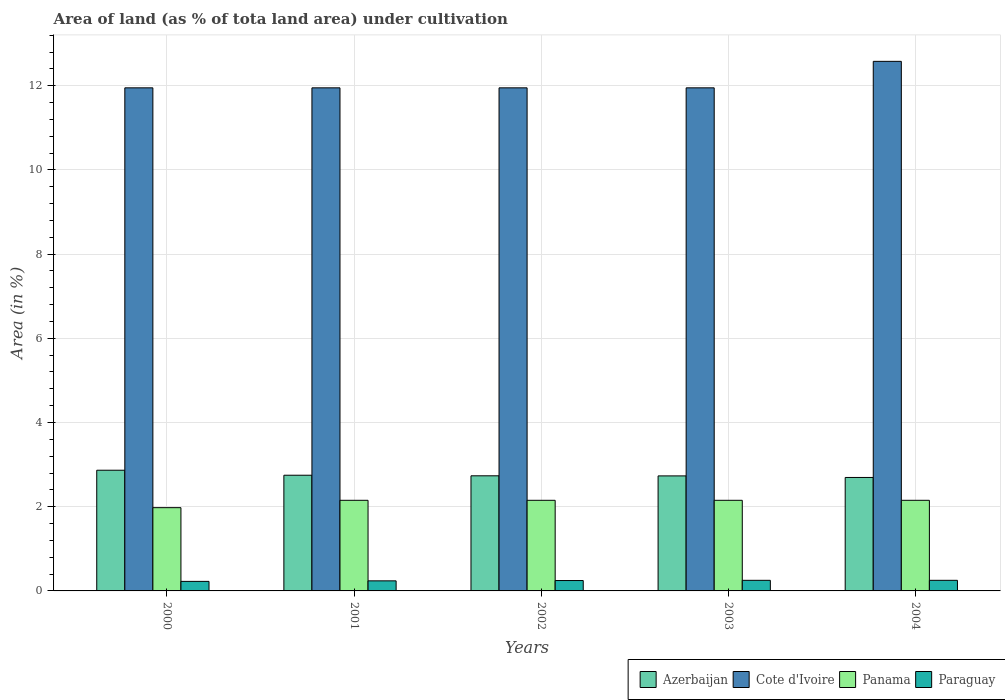How many different coloured bars are there?
Your response must be concise. 4. Are the number of bars per tick equal to the number of legend labels?
Provide a succinct answer. Yes. What is the label of the 1st group of bars from the left?
Make the answer very short. 2000. In how many cases, is the number of bars for a given year not equal to the number of legend labels?
Your answer should be very brief. 0. What is the percentage of land under cultivation in Cote d'Ivoire in 2004?
Give a very brief answer. 12.58. Across all years, what is the maximum percentage of land under cultivation in Azerbaijan?
Keep it short and to the point. 2.87. Across all years, what is the minimum percentage of land under cultivation in Paraguay?
Ensure brevity in your answer.  0.23. In which year was the percentage of land under cultivation in Panama maximum?
Your answer should be very brief. 2001. In which year was the percentage of land under cultivation in Azerbaijan minimum?
Provide a short and direct response. 2004. What is the total percentage of land under cultivation in Azerbaijan in the graph?
Your answer should be compact. 13.78. What is the difference between the percentage of land under cultivation in Panama in 2000 and that in 2003?
Keep it short and to the point. -0.17. What is the difference between the percentage of land under cultivation in Paraguay in 2000 and the percentage of land under cultivation in Cote d'Ivoire in 2004?
Provide a succinct answer. -12.35. What is the average percentage of land under cultivation in Paraguay per year?
Your answer should be compact. 0.24. In the year 2001, what is the difference between the percentage of land under cultivation in Paraguay and percentage of land under cultivation in Panama?
Your answer should be very brief. -1.91. In how many years, is the percentage of land under cultivation in Paraguay greater than 2.4 %?
Keep it short and to the point. 0. What is the ratio of the percentage of land under cultivation in Panama in 2000 to that in 2004?
Your answer should be very brief. 0.92. What is the difference between the highest and the second highest percentage of land under cultivation in Panama?
Your response must be concise. 0. What is the difference between the highest and the lowest percentage of land under cultivation in Cote d'Ivoire?
Your answer should be very brief. 0.63. In how many years, is the percentage of land under cultivation in Panama greater than the average percentage of land under cultivation in Panama taken over all years?
Ensure brevity in your answer.  4. Is it the case that in every year, the sum of the percentage of land under cultivation in Panama and percentage of land under cultivation in Paraguay is greater than the sum of percentage of land under cultivation in Azerbaijan and percentage of land under cultivation in Cote d'Ivoire?
Provide a short and direct response. No. What does the 3rd bar from the left in 2002 represents?
Give a very brief answer. Panama. What does the 1st bar from the right in 2000 represents?
Give a very brief answer. Paraguay. Is it the case that in every year, the sum of the percentage of land under cultivation in Azerbaijan and percentage of land under cultivation in Cote d'Ivoire is greater than the percentage of land under cultivation in Panama?
Your answer should be very brief. Yes. How many bars are there?
Give a very brief answer. 20. Are all the bars in the graph horizontal?
Your response must be concise. No. How many years are there in the graph?
Provide a succinct answer. 5. Does the graph contain grids?
Make the answer very short. Yes. Where does the legend appear in the graph?
Provide a succinct answer. Bottom right. How many legend labels are there?
Offer a terse response. 4. How are the legend labels stacked?
Provide a short and direct response. Horizontal. What is the title of the graph?
Make the answer very short. Area of land (as % of tota land area) under cultivation. What is the label or title of the Y-axis?
Your answer should be compact. Area (in %). What is the Area (in %) of Azerbaijan in 2000?
Your response must be concise. 2.87. What is the Area (in %) of Cote d'Ivoire in 2000?
Ensure brevity in your answer.  11.95. What is the Area (in %) of Panama in 2000?
Your answer should be very brief. 1.98. What is the Area (in %) in Paraguay in 2000?
Provide a succinct answer. 0.23. What is the Area (in %) in Azerbaijan in 2001?
Make the answer very short. 2.75. What is the Area (in %) in Cote d'Ivoire in 2001?
Your response must be concise. 11.95. What is the Area (in %) of Panama in 2001?
Your answer should be very brief. 2.15. What is the Area (in %) in Paraguay in 2001?
Provide a succinct answer. 0.24. What is the Area (in %) in Azerbaijan in 2002?
Make the answer very short. 2.73. What is the Area (in %) of Cote d'Ivoire in 2002?
Your response must be concise. 11.95. What is the Area (in %) of Panama in 2002?
Offer a terse response. 2.15. What is the Area (in %) in Paraguay in 2002?
Give a very brief answer. 0.25. What is the Area (in %) of Azerbaijan in 2003?
Provide a succinct answer. 2.73. What is the Area (in %) of Cote d'Ivoire in 2003?
Keep it short and to the point. 11.95. What is the Area (in %) of Panama in 2003?
Your response must be concise. 2.15. What is the Area (in %) of Paraguay in 2003?
Provide a succinct answer. 0.25. What is the Area (in %) in Azerbaijan in 2004?
Your answer should be compact. 2.69. What is the Area (in %) in Cote d'Ivoire in 2004?
Provide a short and direct response. 12.58. What is the Area (in %) of Panama in 2004?
Provide a succinct answer. 2.15. What is the Area (in %) in Paraguay in 2004?
Provide a succinct answer. 0.25. Across all years, what is the maximum Area (in %) of Azerbaijan?
Give a very brief answer. 2.87. Across all years, what is the maximum Area (in %) of Cote d'Ivoire?
Give a very brief answer. 12.58. Across all years, what is the maximum Area (in %) of Panama?
Offer a terse response. 2.15. Across all years, what is the maximum Area (in %) of Paraguay?
Make the answer very short. 0.25. Across all years, what is the minimum Area (in %) in Azerbaijan?
Give a very brief answer. 2.69. Across all years, what is the minimum Area (in %) of Cote d'Ivoire?
Ensure brevity in your answer.  11.95. Across all years, what is the minimum Area (in %) of Panama?
Provide a short and direct response. 1.98. Across all years, what is the minimum Area (in %) of Paraguay?
Keep it short and to the point. 0.23. What is the total Area (in %) in Azerbaijan in the graph?
Your response must be concise. 13.78. What is the total Area (in %) of Cote d'Ivoire in the graph?
Offer a terse response. 60.38. What is the total Area (in %) of Panama in the graph?
Provide a succinct answer. 10.59. What is the total Area (in %) of Paraguay in the graph?
Your answer should be compact. 1.22. What is the difference between the Area (in %) in Azerbaijan in 2000 and that in 2001?
Make the answer very short. 0.12. What is the difference between the Area (in %) of Panama in 2000 and that in 2001?
Your answer should be very brief. -0.17. What is the difference between the Area (in %) in Paraguay in 2000 and that in 2001?
Your answer should be very brief. -0.01. What is the difference between the Area (in %) in Azerbaijan in 2000 and that in 2002?
Your answer should be very brief. 0.13. What is the difference between the Area (in %) of Panama in 2000 and that in 2002?
Offer a very short reply. -0.17. What is the difference between the Area (in %) of Paraguay in 2000 and that in 2002?
Ensure brevity in your answer.  -0.02. What is the difference between the Area (in %) in Azerbaijan in 2000 and that in 2003?
Ensure brevity in your answer.  0.13. What is the difference between the Area (in %) of Panama in 2000 and that in 2003?
Make the answer very short. -0.17. What is the difference between the Area (in %) in Paraguay in 2000 and that in 2003?
Provide a succinct answer. -0.03. What is the difference between the Area (in %) of Azerbaijan in 2000 and that in 2004?
Offer a terse response. 0.17. What is the difference between the Area (in %) of Cote d'Ivoire in 2000 and that in 2004?
Provide a succinct answer. -0.63. What is the difference between the Area (in %) of Panama in 2000 and that in 2004?
Keep it short and to the point. -0.17. What is the difference between the Area (in %) of Paraguay in 2000 and that in 2004?
Give a very brief answer. -0.03. What is the difference between the Area (in %) of Azerbaijan in 2001 and that in 2002?
Your response must be concise. 0.01. What is the difference between the Area (in %) in Cote d'Ivoire in 2001 and that in 2002?
Offer a terse response. 0. What is the difference between the Area (in %) in Paraguay in 2001 and that in 2002?
Your answer should be very brief. -0.01. What is the difference between the Area (in %) of Azerbaijan in 2001 and that in 2003?
Keep it short and to the point. 0.02. What is the difference between the Area (in %) of Panama in 2001 and that in 2003?
Offer a very short reply. 0. What is the difference between the Area (in %) of Paraguay in 2001 and that in 2003?
Provide a succinct answer. -0.01. What is the difference between the Area (in %) of Azerbaijan in 2001 and that in 2004?
Your answer should be compact. 0.05. What is the difference between the Area (in %) of Cote d'Ivoire in 2001 and that in 2004?
Your answer should be compact. -0.63. What is the difference between the Area (in %) of Panama in 2001 and that in 2004?
Provide a short and direct response. 0. What is the difference between the Area (in %) of Paraguay in 2001 and that in 2004?
Your response must be concise. -0.01. What is the difference between the Area (in %) of Azerbaijan in 2002 and that in 2003?
Your answer should be compact. 0. What is the difference between the Area (in %) of Paraguay in 2002 and that in 2003?
Keep it short and to the point. -0.01. What is the difference between the Area (in %) of Azerbaijan in 2002 and that in 2004?
Provide a succinct answer. 0.04. What is the difference between the Area (in %) in Cote d'Ivoire in 2002 and that in 2004?
Offer a terse response. -0.63. What is the difference between the Area (in %) in Panama in 2002 and that in 2004?
Ensure brevity in your answer.  0. What is the difference between the Area (in %) in Paraguay in 2002 and that in 2004?
Make the answer very short. -0.01. What is the difference between the Area (in %) in Azerbaijan in 2003 and that in 2004?
Provide a short and direct response. 0.04. What is the difference between the Area (in %) in Cote d'Ivoire in 2003 and that in 2004?
Offer a very short reply. -0.63. What is the difference between the Area (in %) of Azerbaijan in 2000 and the Area (in %) of Cote d'Ivoire in 2001?
Offer a terse response. -9.08. What is the difference between the Area (in %) of Azerbaijan in 2000 and the Area (in %) of Panama in 2001?
Ensure brevity in your answer.  0.71. What is the difference between the Area (in %) in Azerbaijan in 2000 and the Area (in %) in Paraguay in 2001?
Ensure brevity in your answer.  2.63. What is the difference between the Area (in %) of Cote d'Ivoire in 2000 and the Area (in %) of Panama in 2001?
Your answer should be compact. 9.8. What is the difference between the Area (in %) of Cote d'Ivoire in 2000 and the Area (in %) of Paraguay in 2001?
Your answer should be compact. 11.71. What is the difference between the Area (in %) of Panama in 2000 and the Area (in %) of Paraguay in 2001?
Your answer should be compact. 1.74. What is the difference between the Area (in %) of Azerbaijan in 2000 and the Area (in %) of Cote d'Ivoire in 2002?
Make the answer very short. -9.08. What is the difference between the Area (in %) of Azerbaijan in 2000 and the Area (in %) of Panama in 2002?
Your answer should be very brief. 0.71. What is the difference between the Area (in %) of Azerbaijan in 2000 and the Area (in %) of Paraguay in 2002?
Offer a terse response. 2.62. What is the difference between the Area (in %) of Cote d'Ivoire in 2000 and the Area (in %) of Panama in 2002?
Make the answer very short. 9.8. What is the difference between the Area (in %) of Cote d'Ivoire in 2000 and the Area (in %) of Paraguay in 2002?
Your answer should be compact. 11.7. What is the difference between the Area (in %) in Panama in 2000 and the Area (in %) in Paraguay in 2002?
Your answer should be compact. 1.73. What is the difference between the Area (in %) in Azerbaijan in 2000 and the Area (in %) in Cote d'Ivoire in 2003?
Your response must be concise. -9.08. What is the difference between the Area (in %) in Azerbaijan in 2000 and the Area (in %) in Panama in 2003?
Provide a short and direct response. 0.71. What is the difference between the Area (in %) in Azerbaijan in 2000 and the Area (in %) in Paraguay in 2003?
Your response must be concise. 2.62. What is the difference between the Area (in %) in Cote d'Ivoire in 2000 and the Area (in %) in Panama in 2003?
Provide a succinct answer. 9.8. What is the difference between the Area (in %) in Cote d'Ivoire in 2000 and the Area (in %) in Paraguay in 2003?
Your answer should be compact. 11.7. What is the difference between the Area (in %) in Panama in 2000 and the Area (in %) in Paraguay in 2003?
Make the answer very short. 1.73. What is the difference between the Area (in %) in Azerbaijan in 2000 and the Area (in %) in Cote d'Ivoire in 2004?
Keep it short and to the point. -9.71. What is the difference between the Area (in %) of Azerbaijan in 2000 and the Area (in %) of Panama in 2004?
Your answer should be compact. 0.71. What is the difference between the Area (in %) of Azerbaijan in 2000 and the Area (in %) of Paraguay in 2004?
Make the answer very short. 2.62. What is the difference between the Area (in %) of Cote d'Ivoire in 2000 and the Area (in %) of Panama in 2004?
Keep it short and to the point. 9.8. What is the difference between the Area (in %) in Cote d'Ivoire in 2000 and the Area (in %) in Paraguay in 2004?
Give a very brief answer. 11.7. What is the difference between the Area (in %) of Panama in 2000 and the Area (in %) of Paraguay in 2004?
Provide a short and direct response. 1.73. What is the difference between the Area (in %) in Azerbaijan in 2001 and the Area (in %) in Cote d'Ivoire in 2002?
Offer a terse response. -9.2. What is the difference between the Area (in %) of Azerbaijan in 2001 and the Area (in %) of Panama in 2002?
Keep it short and to the point. 0.6. What is the difference between the Area (in %) in Azerbaijan in 2001 and the Area (in %) in Paraguay in 2002?
Make the answer very short. 2.5. What is the difference between the Area (in %) of Cote d'Ivoire in 2001 and the Area (in %) of Panama in 2002?
Provide a succinct answer. 9.8. What is the difference between the Area (in %) of Cote d'Ivoire in 2001 and the Area (in %) of Paraguay in 2002?
Keep it short and to the point. 11.7. What is the difference between the Area (in %) of Panama in 2001 and the Area (in %) of Paraguay in 2002?
Offer a very short reply. 1.91. What is the difference between the Area (in %) in Azerbaijan in 2001 and the Area (in %) in Cote d'Ivoire in 2003?
Your response must be concise. -9.2. What is the difference between the Area (in %) of Azerbaijan in 2001 and the Area (in %) of Panama in 2003?
Your answer should be compact. 0.6. What is the difference between the Area (in %) of Azerbaijan in 2001 and the Area (in %) of Paraguay in 2003?
Offer a terse response. 2.5. What is the difference between the Area (in %) of Cote d'Ivoire in 2001 and the Area (in %) of Panama in 2003?
Offer a terse response. 9.8. What is the difference between the Area (in %) in Cote d'Ivoire in 2001 and the Area (in %) in Paraguay in 2003?
Provide a short and direct response. 11.7. What is the difference between the Area (in %) in Panama in 2001 and the Area (in %) in Paraguay in 2003?
Ensure brevity in your answer.  1.9. What is the difference between the Area (in %) in Azerbaijan in 2001 and the Area (in %) in Cote d'Ivoire in 2004?
Your response must be concise. -9.83. What is the difference between the Area (in %) of Azerbaijan in 2001 and the Area (in %) of Panama in 2004?
Offer a very short reply. 0.6. What is the difference between the Area (in %) in Azerbaijan in 2001 and the Area (in %) in Paraguay in 2004?
Give a very brief answer. 2.5. What is the difference between the Area (in %) in Cote d'Ivoire in 2001 and the Area (in %) in Panama in 2004?
Provide a short and direct response. 9.8. What is the difference between the Area (in %) in Cote d'Ivoire in 2001 and the Area (in %) in Paraguay in 2004?
Provide a short and direct response. 11.7. What is the difference between the Area (in %) of Panama in 2001 and the Area (in %) of Paraguay in 2004?
Your answer should be very brief. 1.9. What is the difference between the Area (in %) of Azerbaijan in 2002 and the Area (in %) of Cote d'Ivoire in 2003?
Provide a succinct answer. -9.22. What is the difference between the Area (in %) of Azerbaijan in 2002 and the Area (in %) of Panama in 2003?
Your answer should be very brief. 0.58. What is the difference between the Area (in %) of Azerbaijan in 2002 and the Area (in %) of Paraguay in 2003?
Keep it short and to the point. 2.48. What is the difference between the Area (in %) of Cote d'Ivoire in 2002 and the Area (in %) of Panama in 2003?
Give a very brief answer. 9.8. What is the difference between the Area (in %) in Cote d'Ivoire in 2002 and the Area (in %) in Paraguay in 2003?
Offer a very short reply. 11.7. What is the difference between the Area (in %) of Panama in 2002 and the Area (in %) of Paraguay in 2003?
Offer a very short reply. 1.9. What is the difference between the Area (in %) of Azerbaijan in 2002 and the Area (in %) of Cote d'Ivoire in 2004?
Make the answer very short. -9.84. What is the difference between the Area (in %) of Azerbaijan in 2002 and the Area (in %) of Panama in 2004?
Offer a very short reply. 0.58. What is the difference between the Area (in %) of Azerbaijan in 2002 and the Area (in %) of Paraguay in 2004?
Keep it short and to the point. 2.48. What is the difference between the Area (in %) in Cote d'Ivoire in 2002 and the Area (in %) in Panama in 2004?
Give a very brief answer. 9.8. What is the difference between the Area (in %) in Cote d'Ivoire in 2002 and the Area (in %) in Paraguay in 2004?
Keep it short and to the point. 11.7. What is the difference between the Area (in %) in Panama in 2002 and the Area (in %) in Paraguay in 2004?
Ensure brevity in your answer.  1.9. What is the difference between the Area (in %) of Azerbaijan in 2003 and the Area (in %) of Cote d'Ivoire in 2004?
Give a very brief answer. -9.85. What is the difference between the Area (in %) of Azerbaijan in 2003 and the Area (in %) of Panama in 2004?
Offer a very short reply. 0.58. What is the difference between the Area (in %) in Azerbaijan in 2003 and the Area (in %) in Paraguay in 2004?
Keep it short and to the point. 2.48. What is the difference between the Area (in %) of Cote d'Ivoire in 2003 and the Area (in %) of Panama in 2004?
Give a very brief answer. 9.8. What is the difference between the Area (in %) in Cote d'Ivoire in 2003 and the Area (in %) in Paraguay in 2004?
Offer a very short reply. 11.7. What is the difference between the Area (in %) in Panama in 2003 and the Area (in %) in Paraguay in 2004?
Your answer should be compact. 1.9. What is the average Area (in %) of Azerbaijan per year?
Offer a very short reply. 2.76. What is the average Area (in %) in Cote d'Ivoire per year?
Your response must be concise. 12.08. What is the average Area (in %) in Panama per year?
Give a very brief answer. 2.12. What is the average Area (in %) of Paraguay per year?
Offer a very short reply. 0.24. In the year 2000, what is the difference between the Area (in %) in Azerbaijan and Area (in %) in Cote d'Ivoire?
Ensure brevity in your answer.  -9.08. In the year 2000, what is the difference between the Area (in %) of Azerbaijan and Area (in %) of Panama?
Offer a very short reply. 0.89. In the year 2000, what is the difference between the Area (in %) of Azerbaijan and Area (in %) of Paraguay?
Your response must be concise. 2.64. In the year 2000, what is the difference between the Area (in %) in Cote d'Ivoire and Area (in %) in Panama?
Keep it short and to the point. 9.97. In the year 2000, what is the difference between the Area (in %) of Cote d'Ivoire and Area (in %) of Paraguay?
Provide a short and direct response. 11.72. In the year 2000, what is the difference between the Area (in %) of Panama and Area (in %) of Paraguay?
Ensure brevity in your answer.  1.75. In the year 2001, what is the difference between the Area (in %) of Azerbaijan and Area (in %) of Cote d'Ivoire?
Give a very brief answer. -9.2. In the year 2001, what is the difference between the Area (in %) in Azerbaijan and Area (in %) in Panama?
Ensure brevity in your answer.  0.6. In the year 2001, what is the difference between the Area (in %) in Azerbaijan and Area (in %) in Paraguay?
Offer a terse response. 2.51. In the year 2001, what is the difference between the Area (in %) in Cote d'Ivoire and Area (in %) in Panama?
Offer a very short reply. 9.8. In the year 2001, what is the difference between the Area (in %) in Cote d'Ivoire and Area (in %) in Paraguay?
Provide a succinct answer. 11.71. In the year 2001, what is the difference between the Area (in %) of Panama and Area (in %) of Paraguay?
Your answer should be very brief. 1.91. In the year 2002, what is the difference between the Area (in %) in Azerbaijan and Area (in %) in Cote d'Ivoire?
Your answer should be very brief. -9.22. In the year 2002, what is the difference between the Area (in %) in Azerbaijan and Area (in %) in Panama?
Provide a succinct answer. 0.58. In the year 2002, what is the difference between the Area (in %) of Azerbaijan and Area (in %) of Paraguay?
Provide a succinct answer. 2.49. In the year 2002, what is the difference between the Area (in %) in Cote d'Ivoire and Area (in %) in Panama?
Your answer should be compact. 9.8. In the year 2002, what is the difference between the Area (in %) in Cote d'Ivoire and Area (in %) in Paraguay?
Give a very brief answer. 11.7. In the year 2002, what is the difference between the Area (in %) in Panama and Area (in %) in Paraguay?
Offer a terse response. 1.91. In the year 2003, what is the difference between the Area (in %) in Azerbaijan and Area (in %) in Cote d'Ivoire?
Your answer should be compact. -9.22. In the year 2003, what is the difference between the Area (in %) of Azerbaijan and Area (in %) of Panama?
Your answer should be very brief. 0.58. In the year 2003, what is the difference between the Area (in %) of Azerbaijan and Area (in %) of Paraguay?
Provide a short and direct response. 2.48. In the year 2003, what is the difference between the Area (in %) in Cote d'Ivoire and Area (in %) in Panama?
Ensure brevity in your answer.  9.8. In the year 2003, what is the difference between the Area (in %) in Cote d'Ivoire and Area (in %) in Paraguay?
Make the answer very short. 11.7. In the year 2003, what is the difference between the Area (in %) of Panama and Area (in %) of Paraguay?
Your answer should be compact. 1.9. In the year 2004, what is the difference between the Area (in %) in Azerbaijan and Area (in %) in Cote d'Ivoire?
Make the answer very short. -9.88. In the year 2004, what is the difference between the Area (in %) of Azerbaijan and Area (in %) of Panama?
Your answer should be compact. 0.54. In the year 2004, what is the difference between the Area (in %) of Azerbaijan and Area (in %) of Paraguay?
Your answer should be compact. 2.44. In the year 2004, what is the difference between the Area (in %) of Cote d'Ivoire and Area (in %) of Panama?
Your response must be concise. 10.43. In the year 2004, what is the difference between the Area (in %) of Cote d'Ivoire and Area (in %) of Paraguay?
Your response must be concise. 12.33. In the year 2004, what is the difference between the Area (in %) of Panama and Area (in %) of Paraguay?
Keep it short and to the point. 1.9. What is the ratio of the Area (in %) of Azerbaijan in 2000 to that in 2001?
Offer a terse response. 1.04. What is the ratio of the Area (in %) in Panama in 2000 to that in 2001?
Provide a succinct answer. 0.92. What is the ratio of the Area (in %) in Paraguay in 2000 to that in 2001?
Your answer should be very brief. 0.95. What is the ratio of the Area (in %) in Azerbaijan in 2000 to that in 2002?
Provide a short and direct response. 1.05. What is the ratio of the Area (in %) of Panama in 2000 to that in 2002?
Your response must be concise. 0.92. What is the ratio of the Area (in %) in Paraguay in 2000 to that in 2002?
Offer a terse response. 0.92. What is the ratio of the Area (in %) in Azerbaijan in 2000 to that in 2003?
Make the answer very short. 1.05. What is the ratio of the Area (in %) in Cote d'Ivoire in 2000 to that in 2003?
Offer a terse response. 1. What is the ratio of the Area (in %) in Panama in 2000 to that in 2003?
Your answer should be compact. 0.92. What is the ratio of the Area (in %) of Paraguay in 2000 to that in 2003?
Ensure brevity in your answer.  0.9. What is the ratio of the Area (in %) of Azerbaijan in 2000 to that in 2004?
Your response must be concise. 1.06. What is the ratio of the Area (in %) in Panama in 2000 to that in 2004?
Keep it short and to the point. 0.92. What is the ratio of the Area (in %) of Cote d'Ivoire in 2001 to that in 2002?
Offer a very short reply. 1. What is the ratio of the Area (in %) of Panama in 2001 to that in 2002?
Make the answer very short. 1. What is the ratio of the Area (in %) of Paraguay in 2001 to that in 2002?
Provide a short and direct response. 0.97. What is the ratio of the Area (in %) of Azerbaijan in 2001 to that in 2003?
Your answer should be very brief. 1.01. What is the ratio of the Area (in %) of Azerbaijan in 2001 to that in 2004?
Your response must be concise. 1.02. What is the ratio of the Area (in %) of Paraguay in 2001 to that in 2004?
Ensure brevity in your answer.  0.95. What is the ratio of the Area (in %) of Azerbaijan in 2002 to that in 2003?
Keep it short and to the point. 1. What is the ratio of the Area (in %) in Paraguay in 2002 to that in 2003?
Keep it short and to the point. 0.98. What is the ratio of the Area (in %) in Azerbaijan in 2002 to that in 2004?
Ensure brevity in your answer.  1.01. What is the ratio of the Area (in %) of Azerbaijan in 2003 to that in 2004?
Your answer should be very brief. 1.01. What is the ratio of the Area (in %) in Panama in 2003 to that in 2004?
Provide a succinct answer. 1. What is the ratio of the Area (in %) in Paraguay in 2003 to that in 2004?
Ensure brevity in your answer.  1. What is the difference between the highest and the second highest Area (in %) in Azerbaijan?
Your answer should be very brief. 0.12. What is the difference between the highest and the second highest Area (in %) of Cote d'Ivoire?
Give a very brief answer. 0.63. What is the difference between the highest and the second highest Area (in %) of Panama?
Make the answer very short. 0. What is the difference between the highest and the lowest Area (in %) in Azerbaijan?
Give a very brief answer. 0.17. What is the difference between the highest and the lowest Area (in %) of Cote d'Ivoire?
Your response must be concise. 0.63. What is the difference between the highest and the lowest Area (in %) of Panama?
Offer a terse response. 0.17. What is the difference between the highest and the lowest Area (in %) in Paraguay?
Make the answer very short. 0.03. 